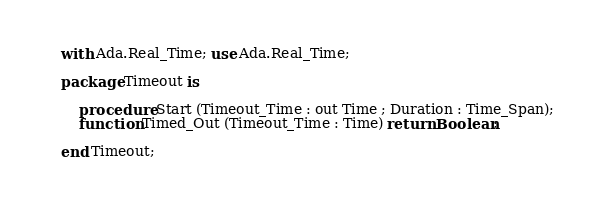<code> <loc_0><loc_0><loc_500><loc_500><_Ada_>with Ada.Real_Time; use Ada.Real_Time;

package Timeout is

	procedure Start (Timeout_Time : out Time ; Duration : Time_Span);
	function Timed_Out (Timeout_Time : Time) return Boolean;

end Timeout;
</code> 